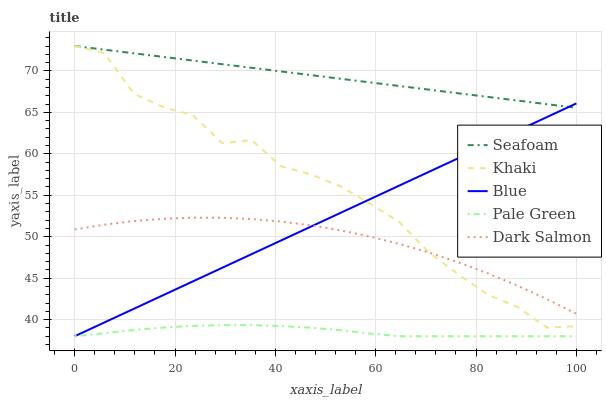Does Pale Green have the minimum area under the curve?
Answer yes or no. Yes. Does Seafoam have the maximum area under the curve?
Answer yes or no. Yes. Does Khaki have the minimum area under the curve?
Answer yes or no. No. Does Khaki have the maximum area under the curve?
Answer yes or no. No. Is Blue the smoothest?
Answer yes or no. Yes. Is Khaki the roughest?
Answer yes or no. Yes. Is Pale Green the smoothest?
Answer yes or no. No. Is Pale Green the roughest?
Answer yes or no. No. Does Blue have the lowest value?
Answer yes or no. Yes. Does Khaki have the lowest value?
Answer yes or no. No. Does Seafoam have the highest value?
Answer yes or no. Yes. Does Pale Green have the highest value?
Answer yes or no. No. Is Pale Green less than Dark Salmon?
Answer yes or no. Yes. Is Dark Salmon greater than Pale Green?
Answer yes or no. Yes. Does Blue intersect Dark Salmon?
Answer yes or no. Yes. Is Blue less than Dark Salmon?
Answer yes or no. No. Is Blue greater than Dark Salmon?
Answer yes or no. No. Does Pale Green intersect Dark Salmon?
Answer yes or no. No. 